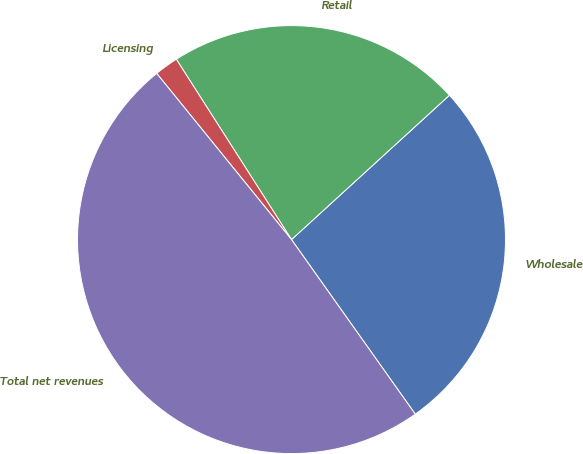<chart> <loc_0><loc_0><loc_500><loc_500><pie_chart><fcel>Wholesale<fcel>Retail<fcel>Licensing<fcel>Total net revenues<nl><fcel>26.97%<fcel>22.26%<fcel>1.8%<fcel>48.97%<nl></chart> 